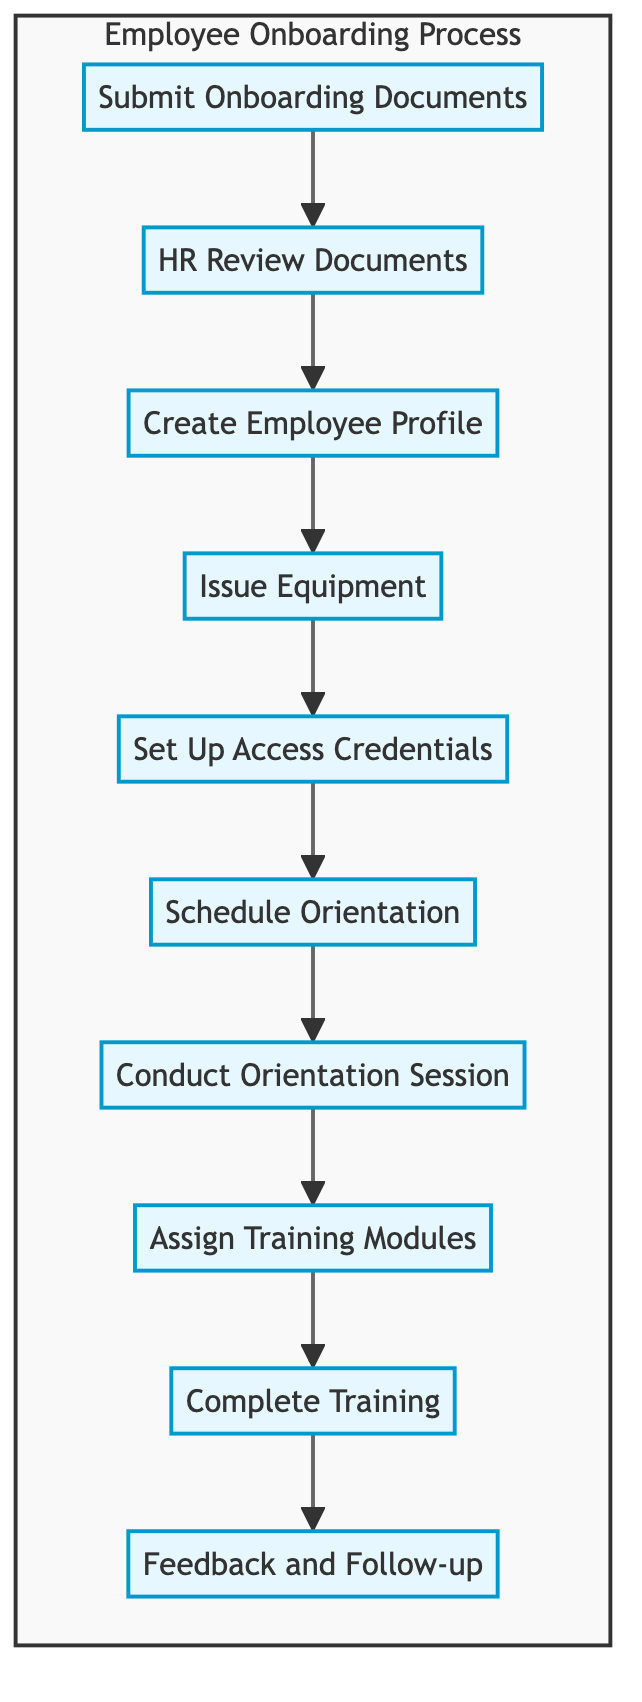What is the first task in the onboarding process? The first task identified in the diagram is "Submit Onboarding Documents," which is the initial action that starts the onboarding process for a new employee.
Answer: Submit Onboarding Documents How many tasks are in the onboarding process? By counting the nodes in the diagram, there are ten distinct tasks listed in the employee onboarding process from submission to follow-up.
Answer: Ten What task follows "Conduct Orientation Session"? The diagram indicates that after "Conduct Orientation Session," the next task is "Assign Training Modules." This shows the sequence of actions taken in the process.
Answer: Assign Training Modules Which department is responsible for issuing equipment? The flow chart specifies that the "IT department" is the responsible party for the task "Issue Equipment," demonstrating its role in preparing necessary tools for the new employee.
Answer: IT department What is necessary before creating the employee profile? Before "Create Employee Profile," the task "HR Review Documents" must be completed to ensure that all required documents are adequately processed and approved.
Answer: HR Review Documents Which task might involve interaction with the new employee? The task "Conduct Orientation Session" definitely involves interaction with the new employee, as it is designed to explain company policies and procedures in a personal setting.
Answer: Conduct Orientation Session What is the last task in the process? The final task in the onboarding process, as indicated in the flow chart, is "Feedback and Follow-up," which takes place after the employee has completed their training.
Answer: Feedback and Follow-up What happens after the "Set Up Access Credentials"? Following the completion of "Set Up Access Credentials," the next task is to "Schedule Orientation," which indicates the continuity of actions for onboarding.
Answer: Schedule Orientation Which task's completion directly leads to training completion? "Assign Training Modules" is the task that directly precedes "Complete Training," indicating it’s a prerequisite for the training phase in the onboarding process.
Answer: Assign Training Modules 